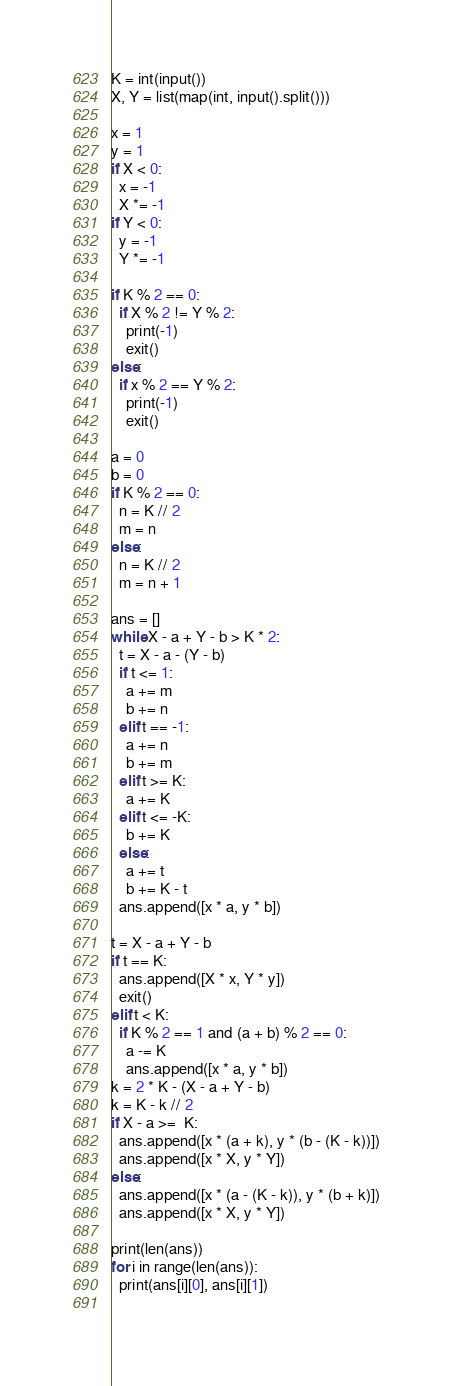Convert code to text. <code><loc_0><loc_0><loc_500><loc_500><_Python_>K = int(input())
X, Y = list(map(int, input().split()))

x = 1
y = 1
if X < 0:
  x = -1
  X *= -1
if Y < 0:
  y = -1
  Y *= -1

if K % 2 == 0:
  if X % 2 != Y % 2:
    print(-1)
    exit()
else:
  if x % 2 == Y % 2:
    print(-1)
    exit()

a = 0
b = 0
if K % 2 == 0:
  n = K // 2
  m = n
else:
  n = K // 2
  m = n + 1

ans = []
while X - a + Y - b > K * 2:
  t = X - a - (Y - b)
  if t <= 1:
    a += m
    b += n
  elif t == -1:
    a += n
    b += m
  elif t >= K:
    a += K
  elif t <= -K:
    b += K
  else:
    a += t
    b += K - t
  ans.append([x * a, y * b])

t = X - a + Y - b
if t == K:
  ans.append([X * x, Y * y])
  exit()
elif t < K:
  if K % 2 == 1 and (a + b) % 2 == 0:
    a -= K
    ans.append([x * a, y * b])
k = 2 * K - (X - a + Y - b)
k = K - k // 2
if X - a >=  K:
  ans.append([x * (a + k), y * (b - (K - k))])
  ans.append([x * X, y * Y])
else:
  ans.append([x * (a - (K - k)), y * (b + k)])
  ans.append([x * X, y * Y])

print(len(ans))
for i in range(len(ans)):
  print(ans[i][0], ans[i][1])
  </code> 